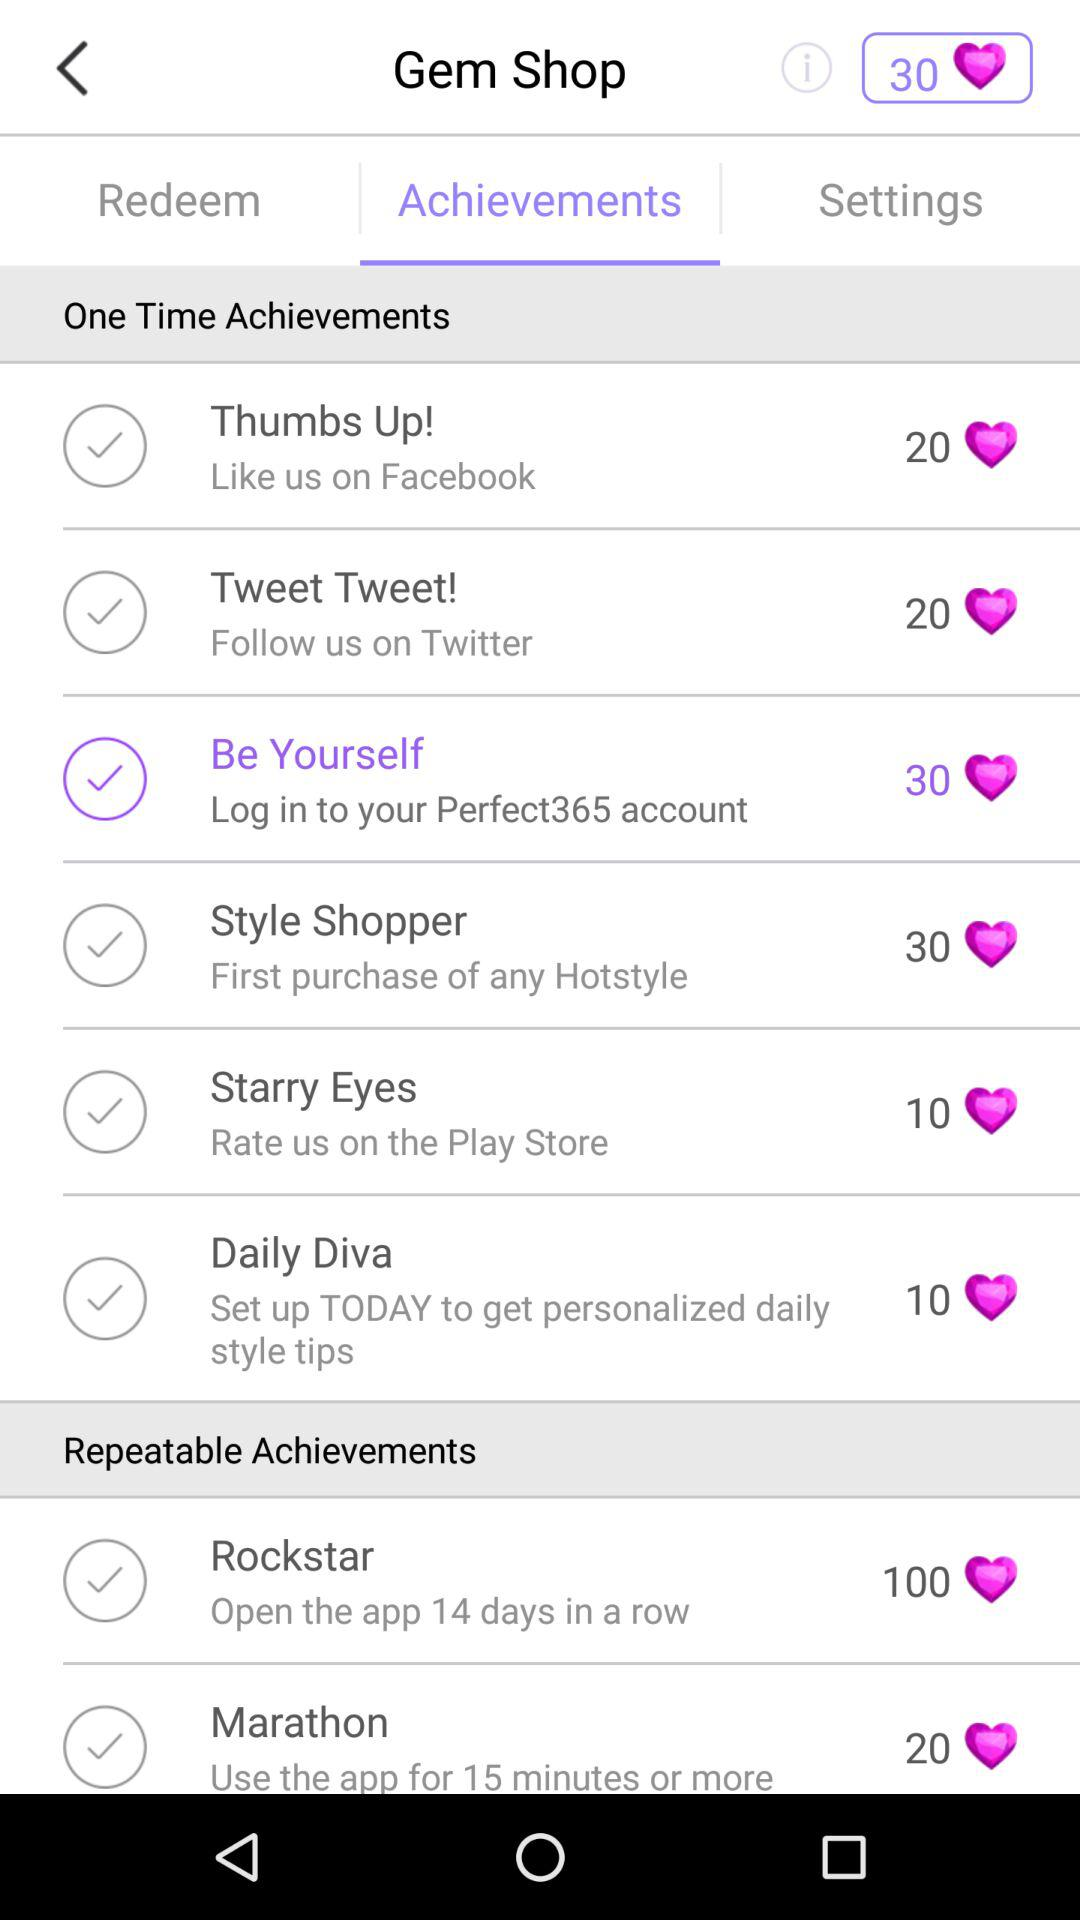Which option has been chosen? The chosen option is "Be Yourself". 